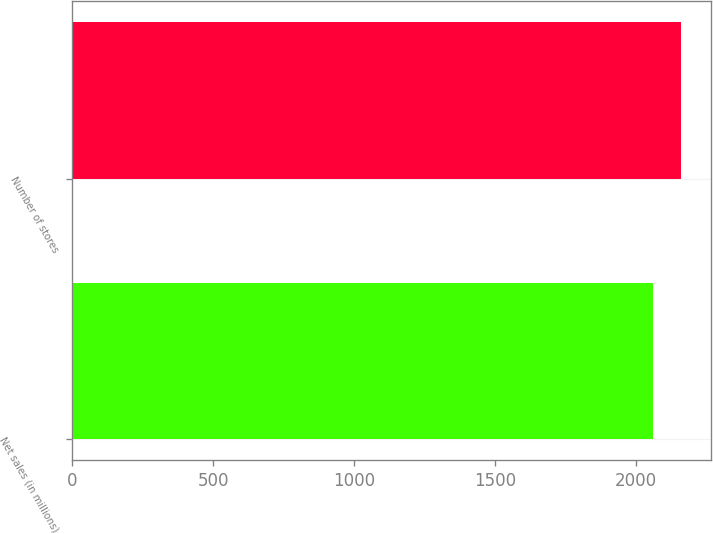Convert chart. <chart><loc_0><loc_0><loc_500><loc_500><bar_chart><fcel>Net sales (in millions)<fcel>Number of stores<nl><fcel>2061.8<fcel>2160<nl></chart> 